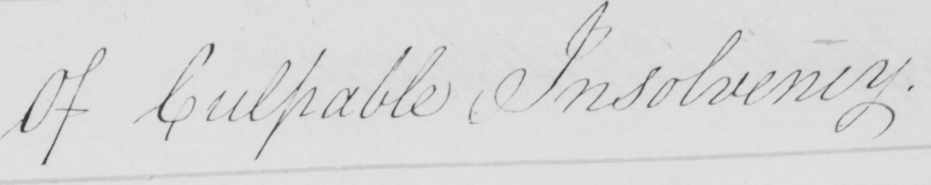Please transcribe the handwritten text in this image. Of Culpable Insolvency . 